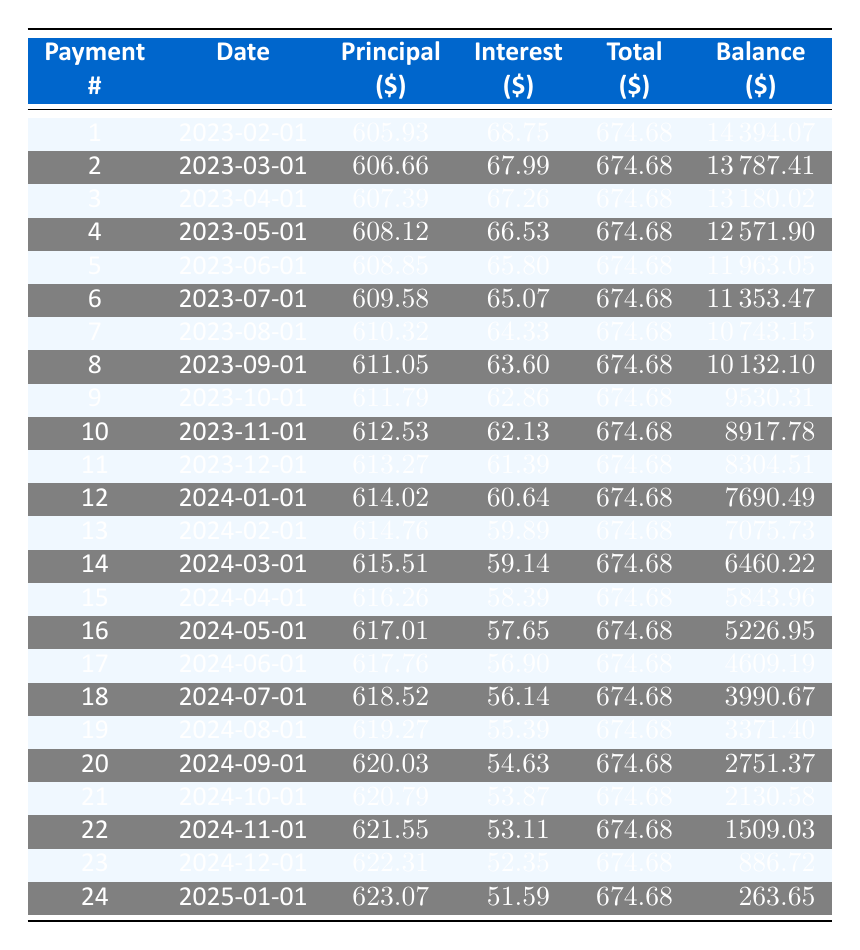What is the total payment amount for the first month? The table shows that for payment number 1, the total payment is listed as 674.68. This value is directly retrieved from the table under the "Total" column for the first row.
Answer: 674.68 What is the remaining balance after the 6th payment? According to the table, after the 6th payment, the remaining balance is 11353.47. This is found in the "Balance" column corresponding to payment number 6.
Answer: 11353.47 How much principal was paid in the last month? The last month's payment number (24) shows a principal payment of 623.07. This amount is obtained by looking under the "Principal" column for payment number 24.
Answer: 623.07 What is the average monthly principal payment over the loan term? To find the average monthly principal payment, sum the principal payment amounts from all 24 payments (total of 14886.93) and divide by the number of payments (24). The average is 14886.93 / 24 = 620.29.
Answer: 620.29 Is the interest payment higher in the first month than in the last month? The interest payment for the first month is 68.75, while the interest payment for the last month is 51.59. Since 68.75 is greater than 51.59, the answer is yes.
Answer: Yes What is the total amount of payments made through the 12th month? To find the total amount paid through the 12th month, we sum the total payments for each month up to the 12th payment. This results in 12 * 674.68 = 8096.16.
Answer: 8096.16 How much more principal is paid in the 24th payment compared to the 1st payment? The principal payment for the 24th payment is 623.07 and for the 1st is 605.93. The difference is 623.07 - 605.93 = 17.14. This shows how much more principal was paid in the last payment compared to the first.
Answer: 17.14 What was the total loan amount borrowed? The total loan amount borrowed is found in the loan details section, which states it is 15000. This does not need calculations as it is provided directly in the loan details.
Answer: 15000 What is the interest payment in the 12th month? For the 12th payment date, the interest payment is indicated as 60.64 in the table. This is taken directly from the "Interest" column for payment number 12.
Answer: 60.64 